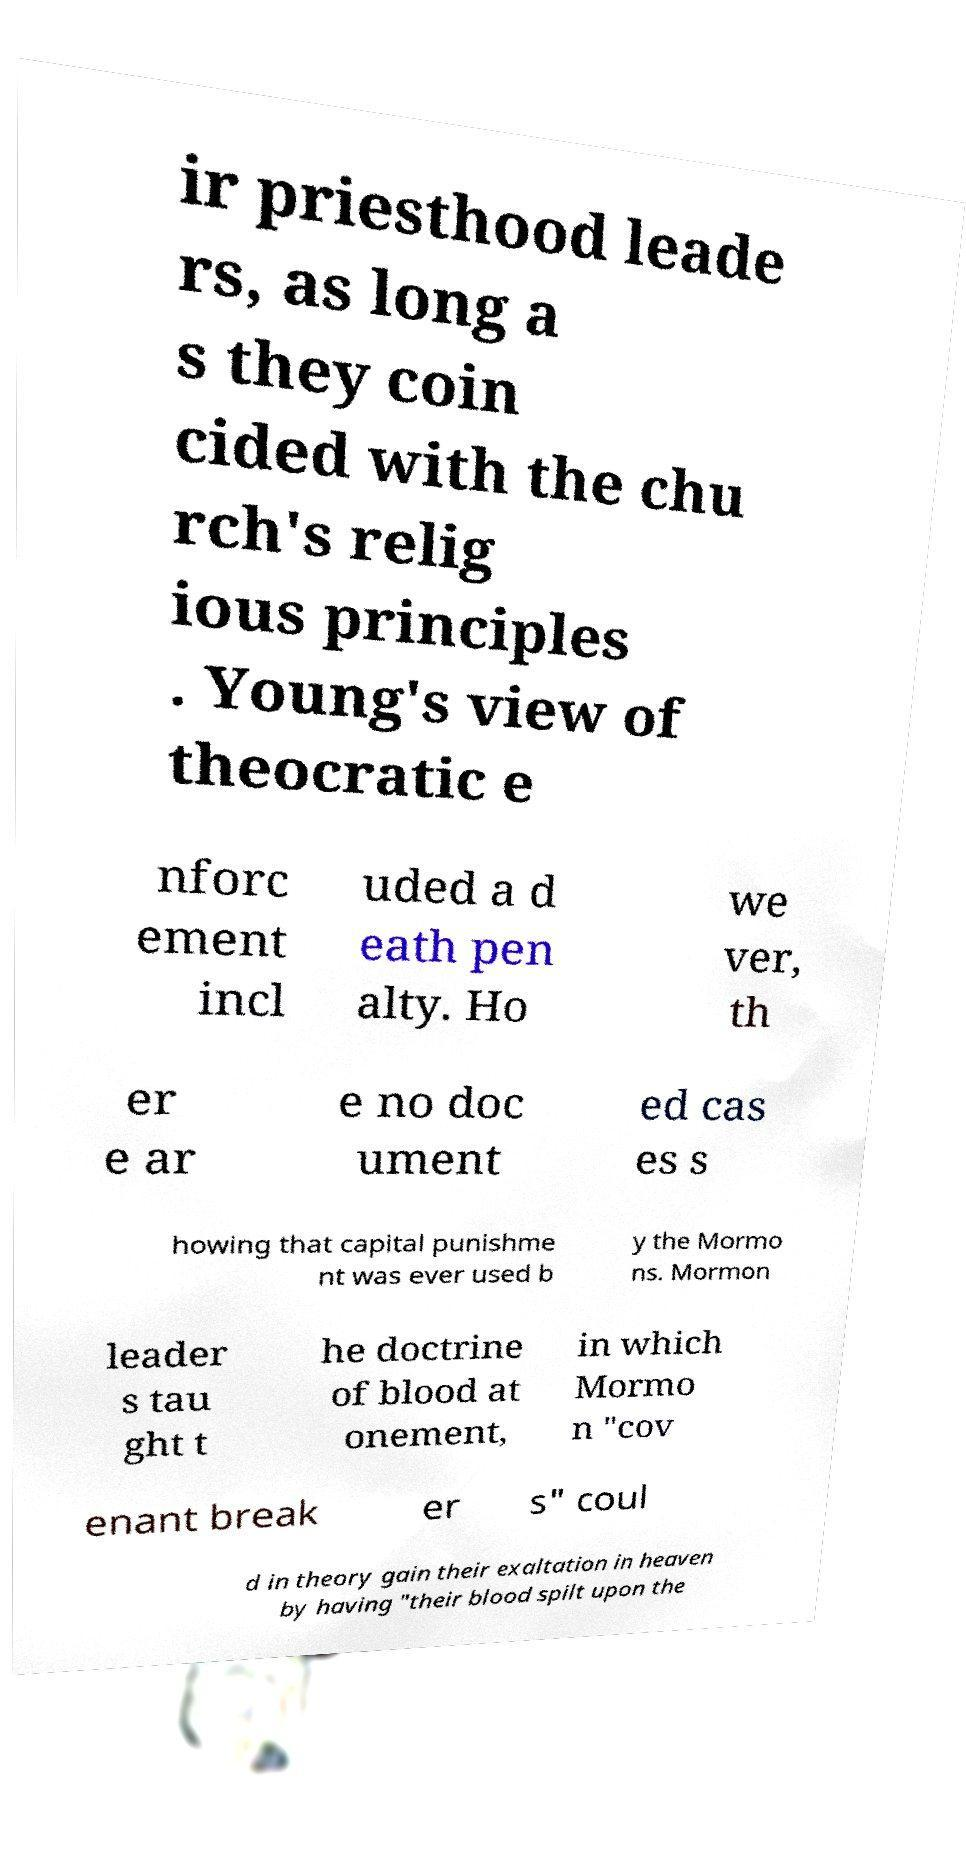I need the written content from this picture converted into text. Can you do that? ir priesthood leade rs, as long a s they coin cided with the chu rch's relig ious principles . Young's view of theocratic e nforc ement incl uded a d eath pen alty. Ho we ver, th er e ar e no doc ument ed cas es s howing that capital punishme nt was ever used b y the Mormo ns. Mormon leader s tau ght t he doctrine of blood at onement, in which Mormo n "cov enant break er s" coul d in theory gain their exaltation in heaven by having "their blood spilt upon the 